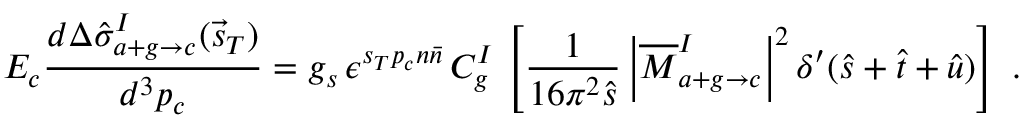Convert formula to latex. <formula><loc_0><loc_0><loc_500><loc_500>E _ { c } \frac { d \Delta \hat { \sigma } _ { a + g \rightarrow c } ^ { I } ( \vec { s } _ { T } ) } { d ^ { 3 } p _ { c } } = g _ { s } \, \epsilon ^ { s _ { T } p _ { c } n \bar { n } } \, C _ { g } ^ { I } \, \left [ \frac { 1 } { 1 6 \pi ^ { 2 } \hat { s } } \left | \overline { M } _ { a + g \rightarrow c } ^ { I } \right | ^ { 2 } \delta ^ { \prime } ( \hat { s } + \hat { t } + \hat { u } ) \right ] \ .</formula> 